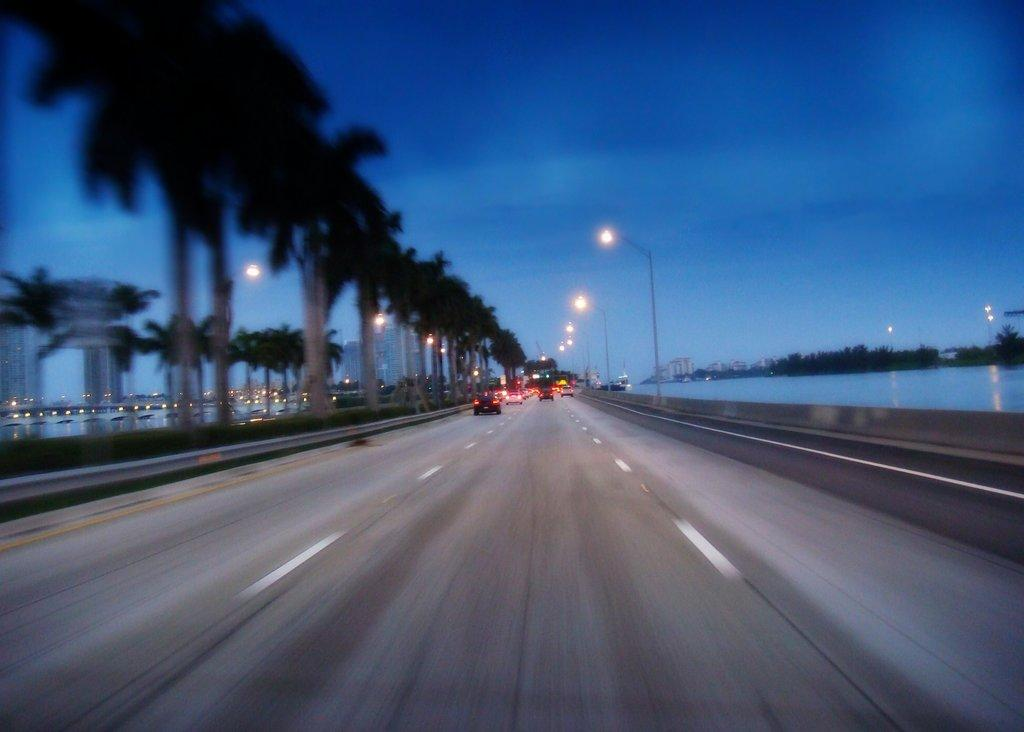What can be seen on the road in the image? There are vehicles on the road in the image. What type of illumination is visible in the image? There are lights visible in the image. What type of natural elements can be seen in the image? There are trees present in the image, and in the background, there are trees and water visible. What type of man-made structures can be seen in the background? There are buildings in the background. What type of infrastructure can be seen in the background? There are light poles in the background. What type of atmospheric conditions can be seen in the background? There are clouds in the sky in the background. What type of hair can be seen on the vehicles in the image? There is no hair present on the vehicles in the image. What type of plastic material can be seen in the image? There is no plastic material mentioned in the provided facts, so it cannot be determined from the image. 